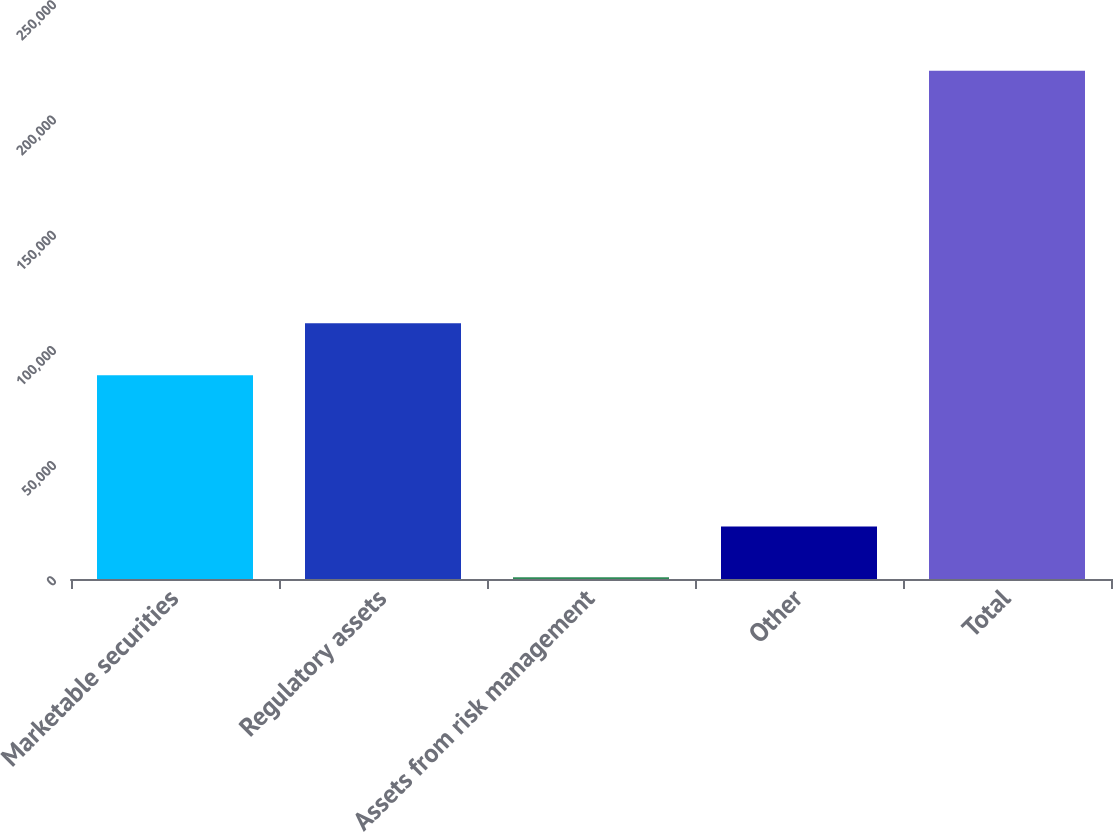Convert chart. <chart><loc_0><loc_0><loc_500><loc_500><bar_chart><fcel>Marketable securities<fcel>Regulatory assets<fcel>Assets from risk management<fcel>Other<fcel>Total<nl><fcel>88409<fcel>110977<fcel>803<fcel>22786.3<fcel>220636<nl></chart> 